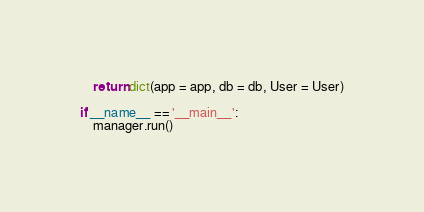<code> <loc_0><loc_0><loc_500><loc_500><_Python_>    return dict(app = app, db = db, User = User)

if __name__ == '__main__':
    manager.run()</code> 